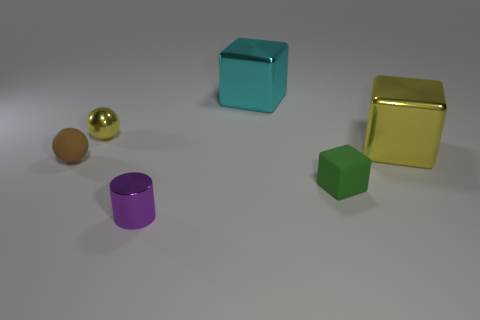There is a thing that is the same color as the small metal ball; what size is it?
Make the answer very short. Large. What shape is the large yellow object?
Your response must be concise. Cube. There is a tiny object that is on the left side of the yellow object that is to the left of the shiny cylinder; what shape is it?
Provide a short and direct response. Sphere. What number of other objects are the same shape as the large cyan thing?
Offer a very short reply. 2. What size is the yellow metallic object that is to the right of the metal thing in front of the small brown object?
Offer a terse response. Large. Are there any small yellow spheres?
Provide a succinct answer. Yes. There is a metal thing on the right side of the tiny green rubber object; what number of cubes are behind it?
Provide a short and direct response. 1. There is a tiny metallic thing that is in front of the small brown rubber sphere; what shape is it?
Give a very brief answer. Cylinder. What is the small object behind the metallic thing right of the metallic cube that is left of the small block made of?
Ensure brevity in your answer.  Metal. What number of other things are there of the same size as the green object?
Your answer should be compact. 3. 